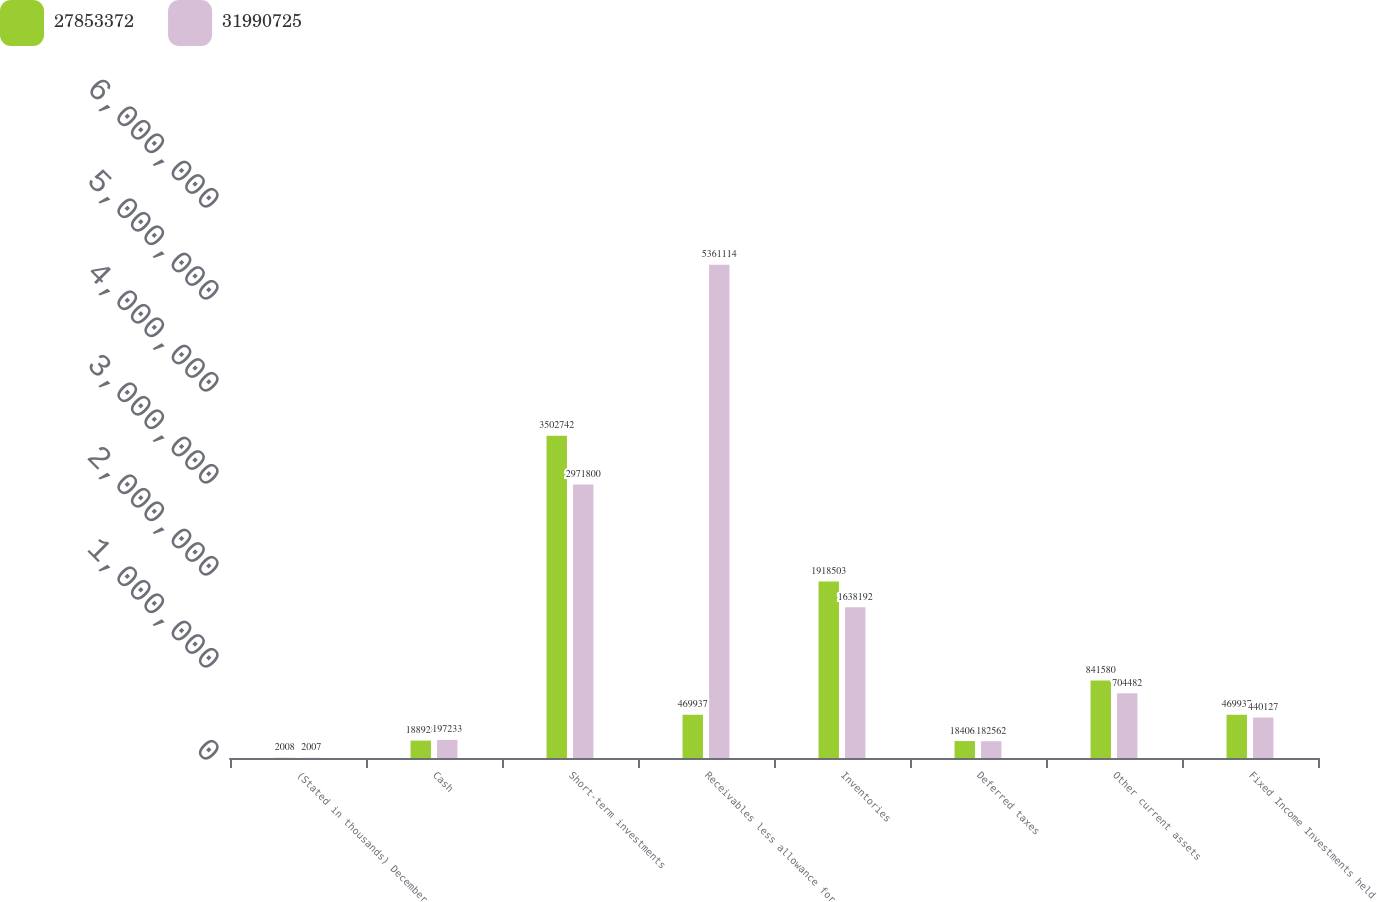Convert chart. <chart><loc_0><loc_0><loc_500><loc_500><stacked_bar_chart><ecel><fcel>(Stated in thousands) December<fcel>Cash<fcel>Short-term investments<fcel>Receivables less allowance for<fcel>Inventories<fcel>Deferred taxes<fcel>Other current assets<fcel>Fixed Income Investments held<nl><fcel>2.78534e+07<fcel>2008<fcel>188928<fcel>3.50274e+06<fcel>469937<fcel>1.9185e+06<fcel>184063<fcel>841580<fcel>469937<nl><fcel>3.19907e+07<fcel>2007<fcel>197233<fcel>2.9718e+06<fcel>5.36111e+06<fcel>1.63819e+06<fcel>182562<fcel>704482<fcel>440127<nl></chart> 